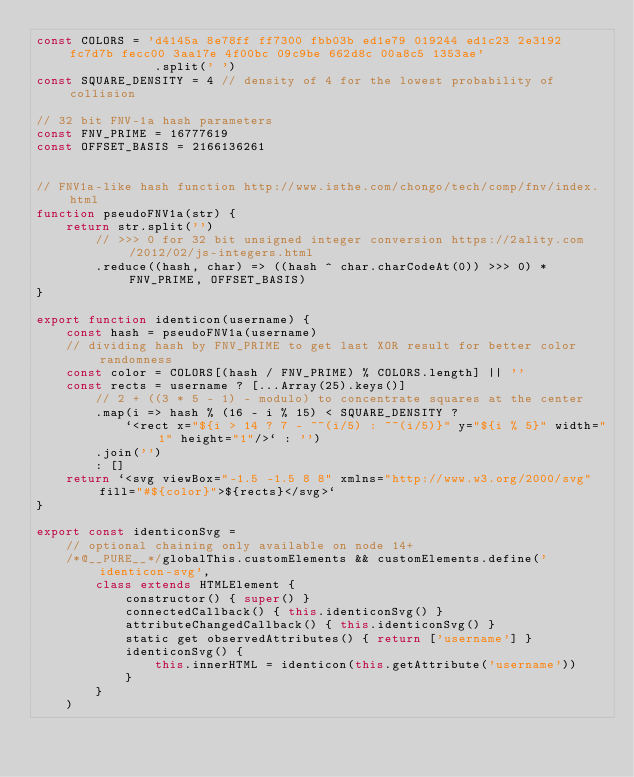Convert code to text. <code><loc_0><loc_0><loc_500><loc_500><_JavaScript_>const COLORS = 'd4145a 8e78ff ff7300 fbb03b ed1e79 019244 ed1c23 2e3192 fc7d7b fecc00 3aa17e 4f00bc 09c9be 662d8c 00a8c5 1353ae'
                .split(' ')
const SQUARE_DENSITY = 4 // density of 4 for the lowest probability of collision

// 32 bit FNV-1a hash parameters
const FNV_PRIME = 16777619
const OFFSET_BASIS = 2166136261


// FNV1a-like hash function http://www.isthe.com/chongo/tech/comp/fnv/index.html
function pseudoFNV1a(str) {
    return str.split('')
        // >>> 0 for 32 bit unsigned integer conversion https://2ality.com/2012/02/js-integers.html
        .reduce((hash, char) => ((hash ^ char.charCodeAt(0)) >>> 0) * FNV_PRIME, OFFSET_BASIS)
}

export function identicon(username) {
    const hash = pseudoFNV1a(username)
    // dividing hash by FNV_PRIME to get last XOR result for better color randomness
    const color = COLORS[(hash / FNV_PRIME) % COLORS.length] || ''
    const rects = username ? [...Array(25).keys()]
        // 2 + ((3 * 5 - 1) - modulo) to concentrate squares at the center
        .map(i => hash % (16 - i % 15) < SQUARE_DENSITY ?
            `<rect x="${i > 14 ? 7 - ~~(i/5) : ~~(i/5)}" y="${i % 5}" width="1" height="1"/>` : '')
        .join('')
        : []
    return `<svg viewBox="-1.5 -1.5 8 8" xmlns="http://www.w3.org/2000/svg" fill="#${color}">${rects}</svg>`
}

export const identiconSvg =
    // optional chaining only available on node 14+
    /*@__PURE__*/globalThis.customElements && customElements.define('identicon-svg',
        class extends HTMLElement {
            constructor() { super() }
            connectedCallback() { this.identiconSvg() }
            attributeChangedCallback() { this.identiconSvg() }
            static get observedAttributes() { return ['username'] }
            identiconSvg() {
                this.innerHTML = identicon(this.getAttribute('username'))
            }
        }
    )
</code> 